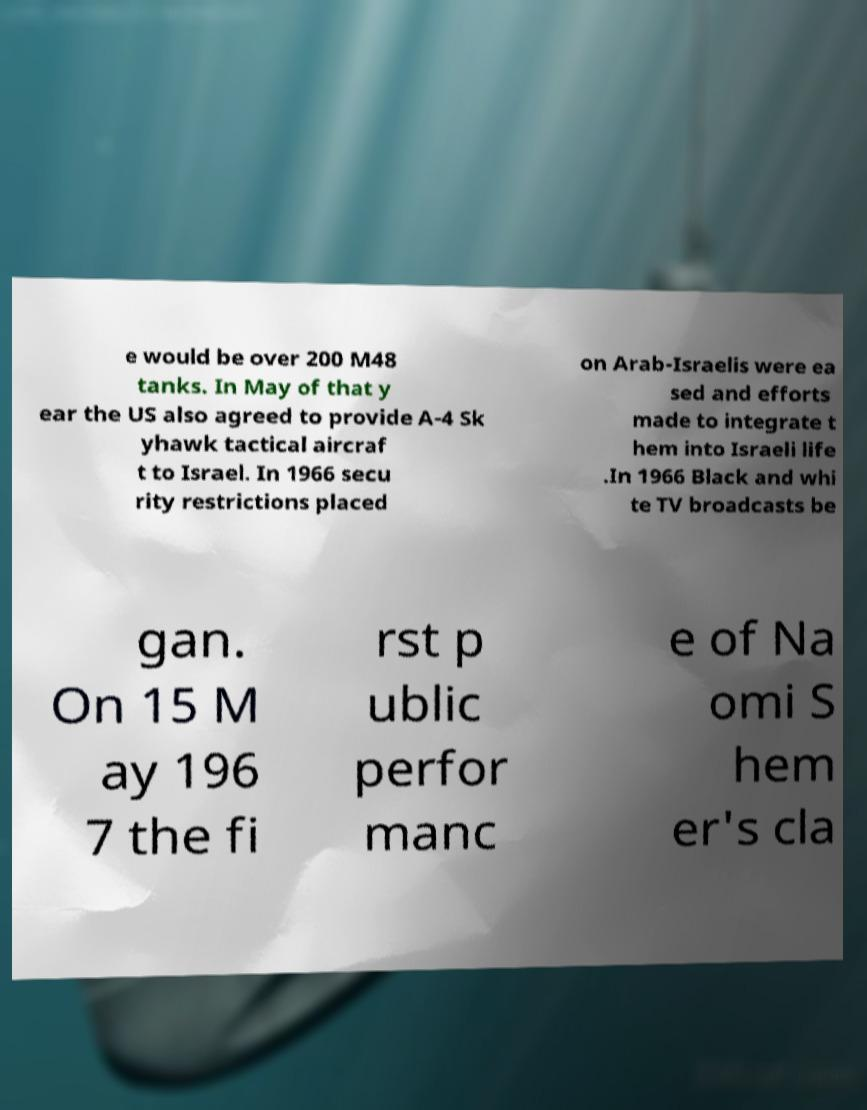Could you assist in decoding the text presented in this image and type it out clearly? e would be over 200 M48 tanks. In May of that y ear the US also agreed to provide A-4 Sk yhawk tactical aircraf t to Israel. In 1966 secu rity restrictions placed on Arab-Israelis were ea sed and efforts made to integrate t hem into Israeli life .In 1966 Black and whi te TV broadcasts be gan. On 15 M ay 196 7 the fi rst p ublic perfor manc e of Na omi S hem er's cla 